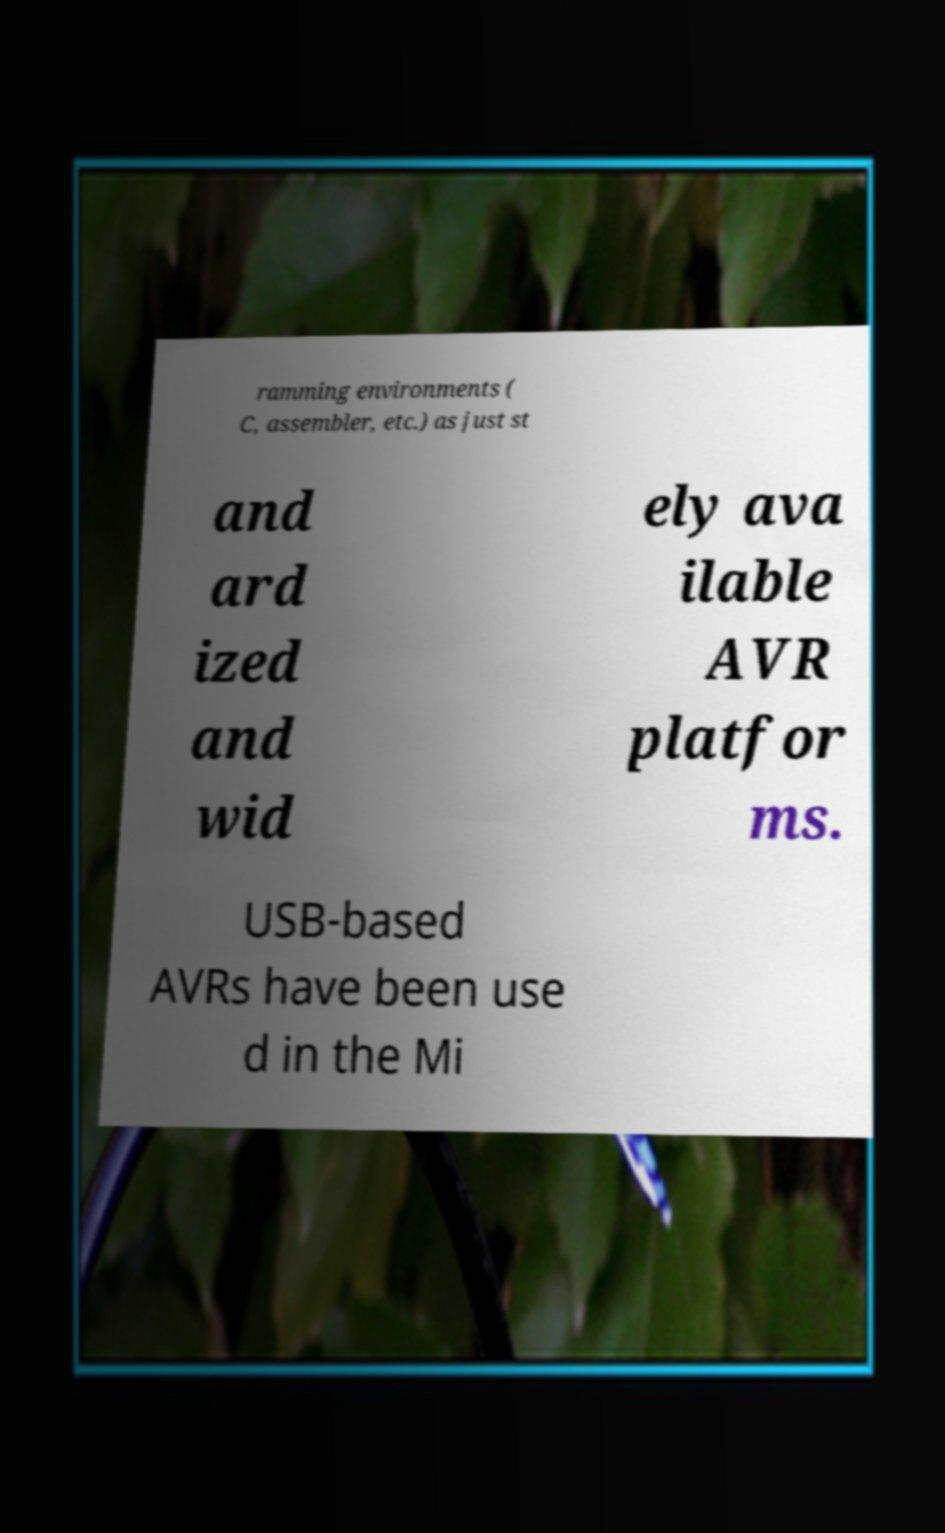Can you accurately transcribe the text from the provided image for me? ramming environments ( C, assembler, etc.) as just st and ard ized and wid ely ava ilable AVR platfor ms. USB-based AVRs have been use d in the Mi 